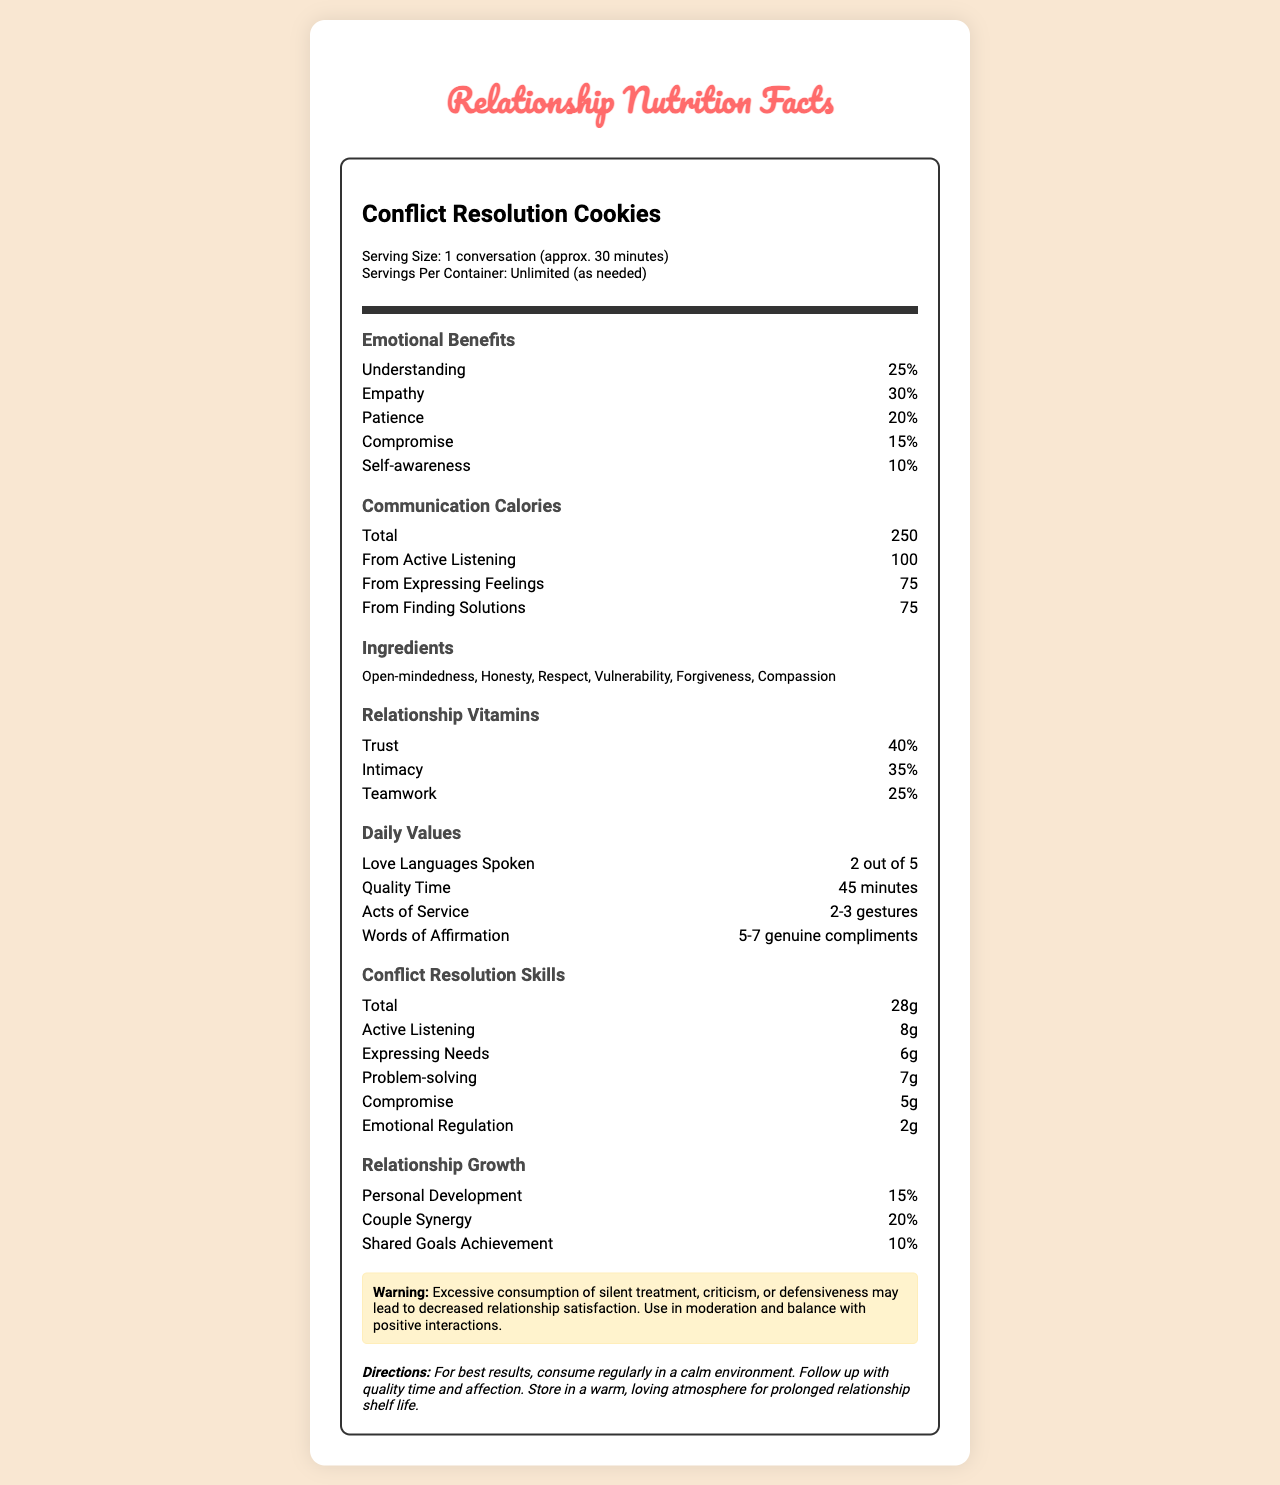what is the serving size of Conflict Resolution Cookies? The document specifies the serving size as "1 conversation (approx. 30 minutes)."
Answer: 1 conversation (approx. 30 minutes) how many servings per container are there? The label mentions that the servings per container are unlimited and can be taken as needed.
Answer: Unlimited (as needed) what are the two main sources of communication calories? The two main sources of communication calories are "From Active Listening" (100) and "From Expressing Feelings" (75).
Answer: From Active Listening and From Expressing Feelings list three ingredients found in Conflict Resolution Cookies. The section titled "Ingredients" lists several ingredients, including Open-mindedness, Honesty, and Respect.
Answer: Open-mindedness, Honesty, Respect how much empathy is provided as an emotional benefit? The document lists empathy as providing a 30% emotional benefit.
Answer: 30% Which of the following is NOT an ingredient in Conflict Resolution Cookies? A. Vulnerability B. Patience C. Forgiveness D. Compassion Patience is listed as an Emotional Benefit, not an ingredient.
Answer: B how many grams of active listening are included in conflict resolution skills? The "Conflict Resolution Skills" section lists Active Listening as contributing 8g.
Answer: 8g how many genuine compliments are included in the daily values? The Daily Values section states "Words of Affirmation: 5-7 genuine compliments."
Answer: 5-7 genuine compliments what is the main warning stated on the label? The Warning section explicitly mentions the potential negative impact of excessive silent treatment, criticism, or defensiveness.
Answer: Excessive consumption of silent treatment, criticism, or defensiveness may lead to decreased relationship satisfaction. how much quality time is recommended daily according to the label? The Daily Values section states the recommended quality time as 45 minutes.
Answer: 45 minutes what percentage of intimacy is provided as a relationship vitamin? The document lists intimacy as providing a 35% relationship vitamin.
Answer: 35% Which of the following skills contributes the least to conflict resolution? A. Active Listening B. Expressing Needs C. Problem-solving D. Emotional Regulation Emotional Regulation contributes 2g, which is the least amount compared to the other skills.
Answer: D is compromise considered both an emotional benefit and a conflict resolution skill? Compromise is listed in both sections: Emotional Benefits (15%) and Conflict Resolution Skills (5g).
Answer: Yes what is the main idea of the document? The document creatively uses a nutrition label format to present important aspects and techniques for conflict resolution within relationships, highlighting their benefits and recommended usage.
Answer: The document outlines the "nutrition facts" of Conflict Resolution Cookies, detailing various components such as emotional benefits, communication calories, relationship vitamins, daily values, conflict resolution skills, and providing directions and warnings for optimal relationship growth. how much percentage is allocated to shared goals achievement in relationship growth? The Relationship Growth section lists Shared Goals Achievement at 10%.
Answer: 10% does the document provide information on where to buy Conflict Resolution Cookies? The document does not provide any information on where to buy Conflict Resolution Cookies, as it focuses on the components and benefits of conflict resolution in relationships.
Answer: Cannot be determined 